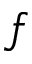<formula> <loc_0><loc_0><loc_500><loc_500>f</formula> 